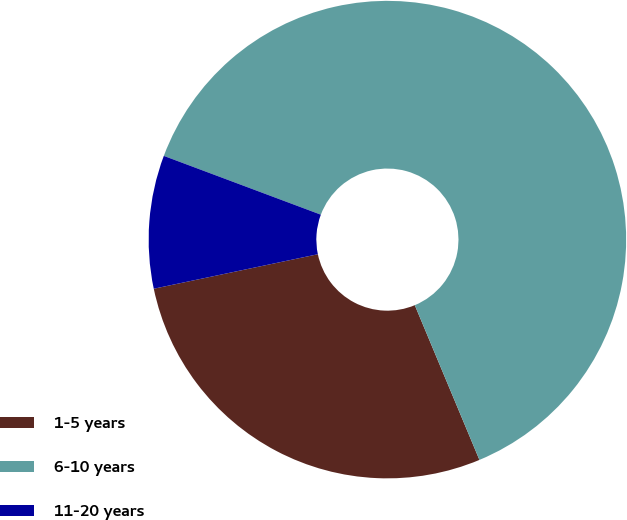Convert chart to OTSL. <chart><loc_0><loc_0><loc_500><loc_500><pie_chart><fcel>1-5 years<fcel>6-10 years<fcel>11-20 years<nl><fcel>28.0%<fcel>63.0%<fcel>9.0%<nl></chart> 